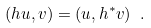<formula> <loc_0><loc_0><loc_500><loc_500>( h u , v ) = ( u , h ^ { * } v ) \ .</formula> 